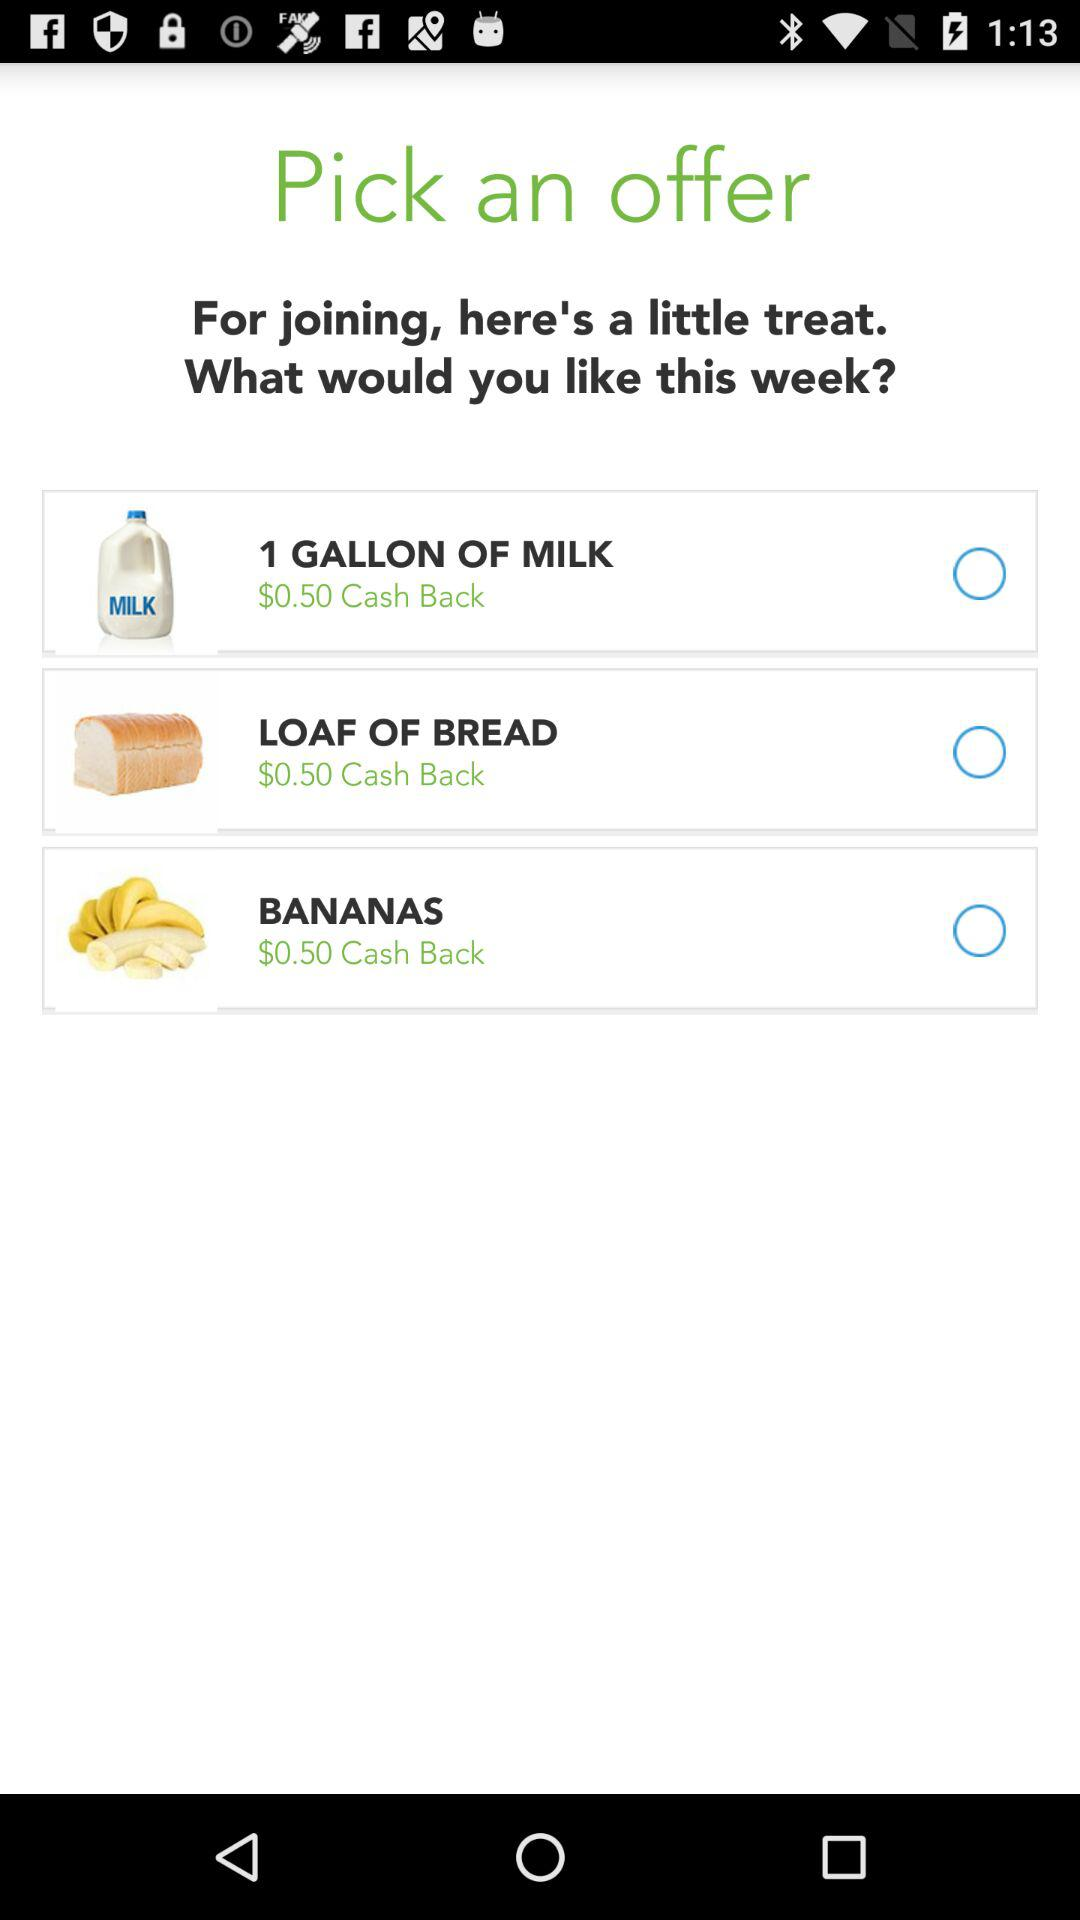How many items are offered?
Answer the question using a single word or phrase. 3 